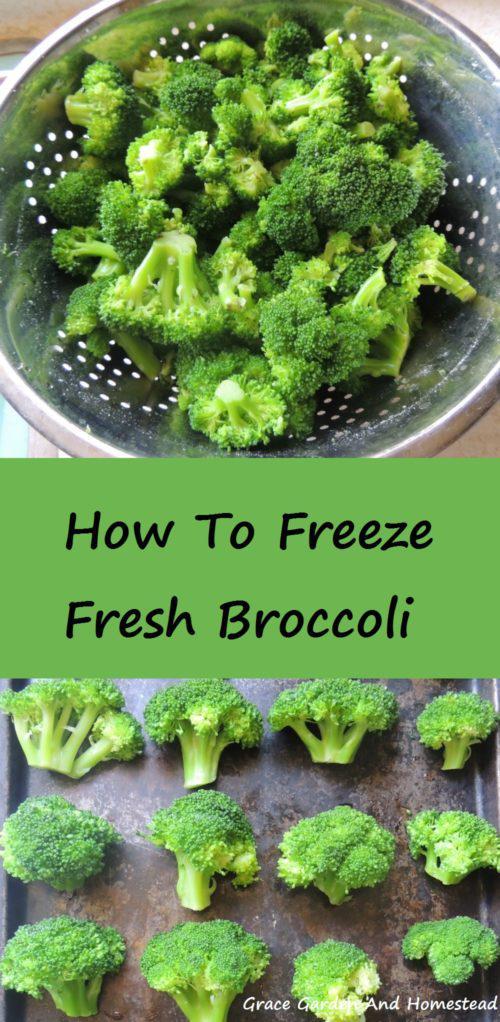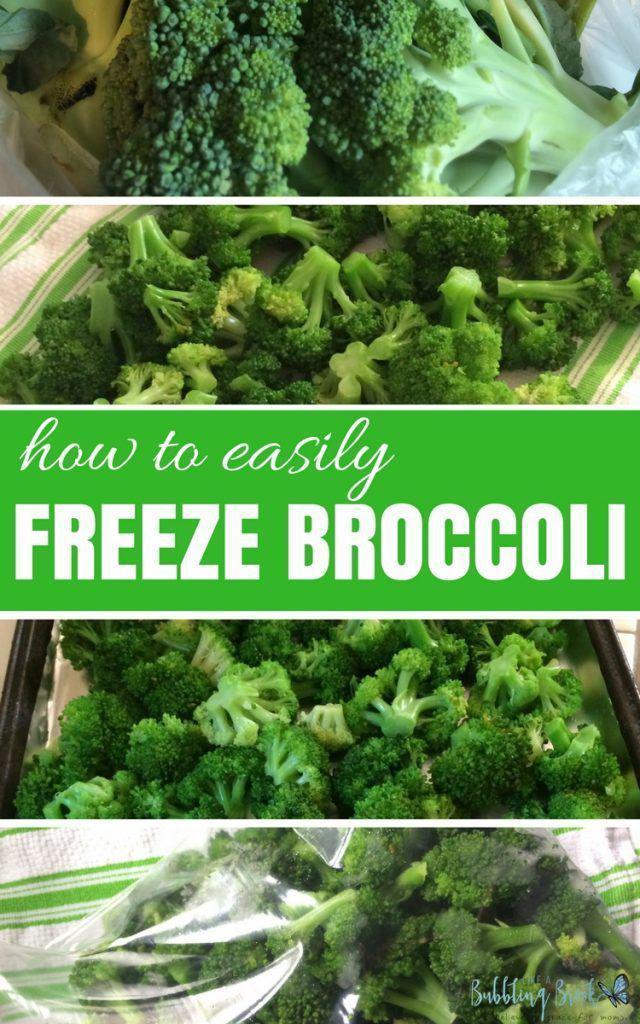The first image is the image on the left, the second image is the image on the right. Given the left and right images, does the statement "There is a single bunch of brocolli in the image on the left." hold true? Answer yes or no. No. The first image is the image on the left, the second image is the image on the right. Evaluate the accuracy of this statement regarding the images: "There is exactly one book about growing broccoli.". Is it true? Answer yes or no. No. 